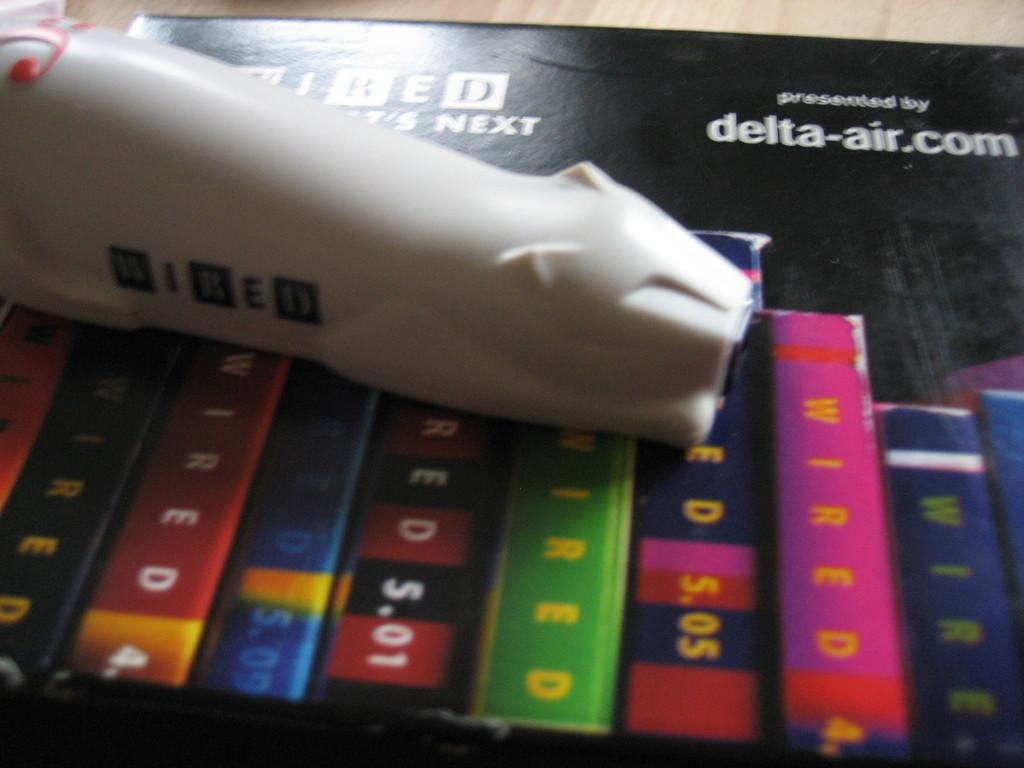<image>
Offer a succinct explanation of the picture presented. A cat figurine is sitting on top of books next to an ad for detla-air.com 